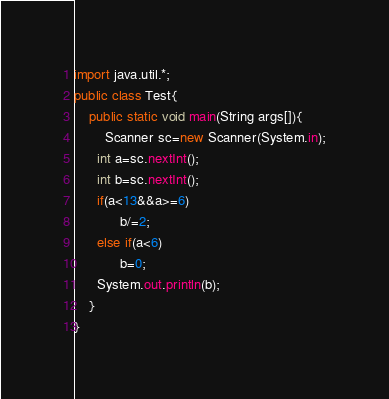Convert code to text. <code><loc_0><loc_0><loc_500><loc_500><_Java_>import java.util.*;
public class Test{
 	public static void main(String args[]){
     	Scanner sc=new Scanner(System.in);
      int a=sc.nextInt();
      int b=sc.nextInt();
      if(a<13&&a>=6)
        	b/=2;
      else if(a<6)
        	b=0;
      System.out.println(b);
    }
}</code> 